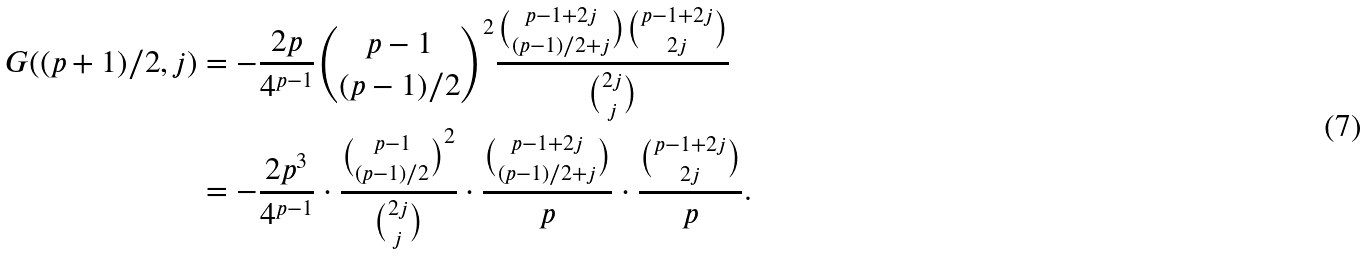Convert formula to latex. <formula><loc_0><loc_0><loc_500><loc_500>G ( ( p + 1 ) / 2 , j ) & = - \frac { 2 p } { 4 ^ { p - 1 } } \binom { p - 1 } { ( p - 1 ) / 2 } ^ { 2 } \frac { \binom { p - 1 + 2 j } { ( p - 1 ) / 2 + j } \binom { p - 1 + 2 j } { 2 j } } { \binom { 2 j } { j } } \\ & = - \frac { 2 p ^ { 3 } } { 4 ^ { p - 1 } } \cdot \frac { \binom { p - 1 } { ( p - 1 ) / 2 } ^ { 2 } } { \binom { 2 j } { j } } \cdot \frac { \binom { p - 1 + 2 j } { ( p - 1 ) / 2 + j } } { p } \cdot \frac { \binom { p - 1 + 2 j } { 2 j } } { p } .</formula> 